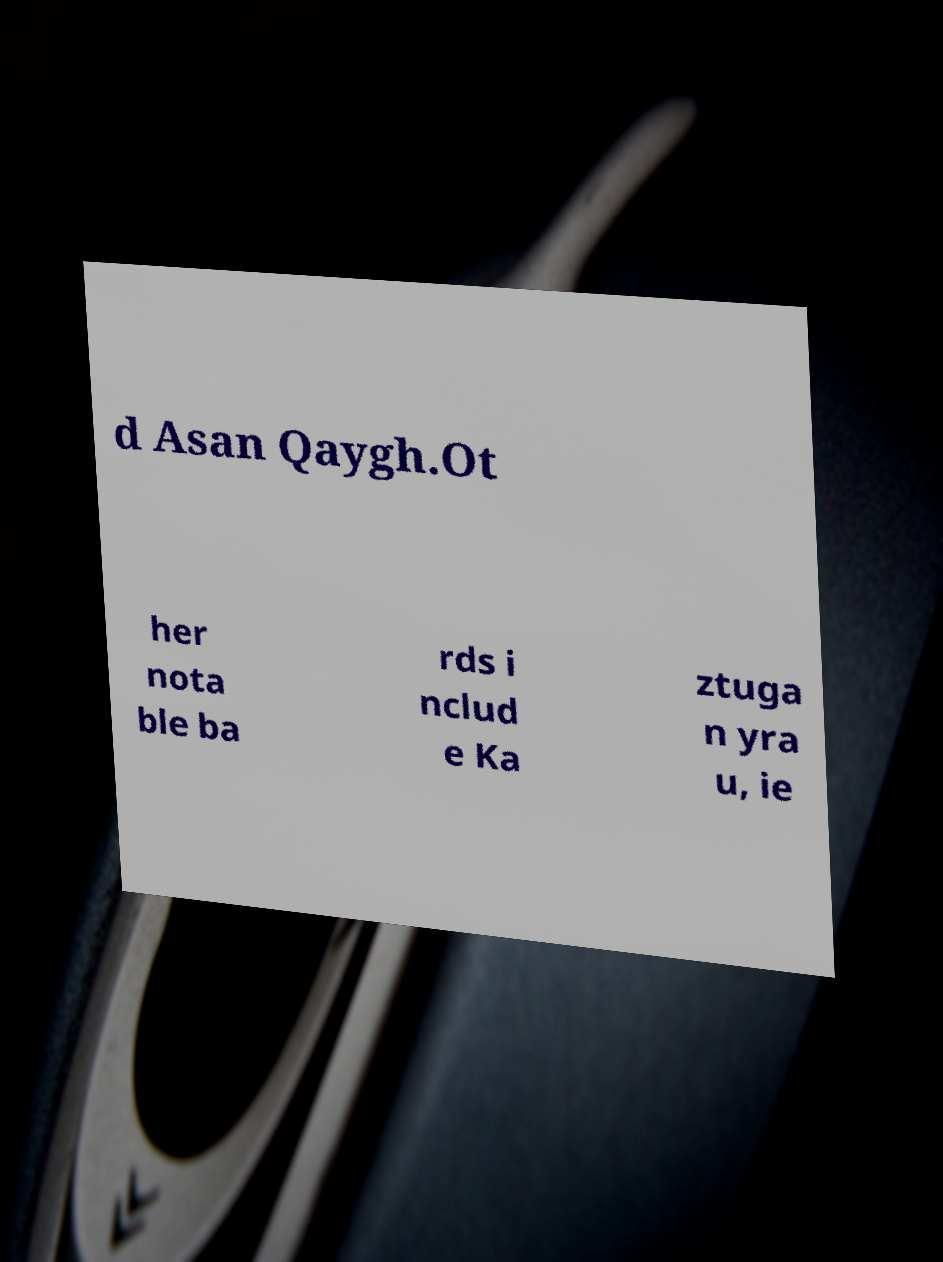For documentation purposes, I need the text within this image transcribed. Could you provide that? d Asan Qaygh.Ot her nota ble ba rds i nclud e Ka ztuga n yra u, ie 